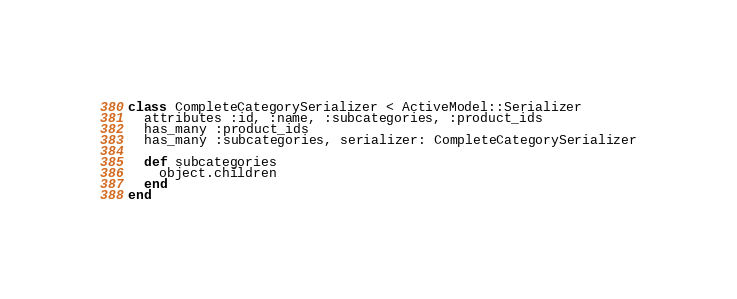Convert code to text. <code><loc_0><loc_0><loc_500><loc_500><_Ruby_>class CompleteCategorySerializer < ActiveModel::Serializer
  attributes :id, :name, :subcategories, :product_ids
  has_many :product_ids
  has_many :subcategories, serializer: CompleteCategorySerializer

  def subcategories
    object.children
  end
end
</code> 